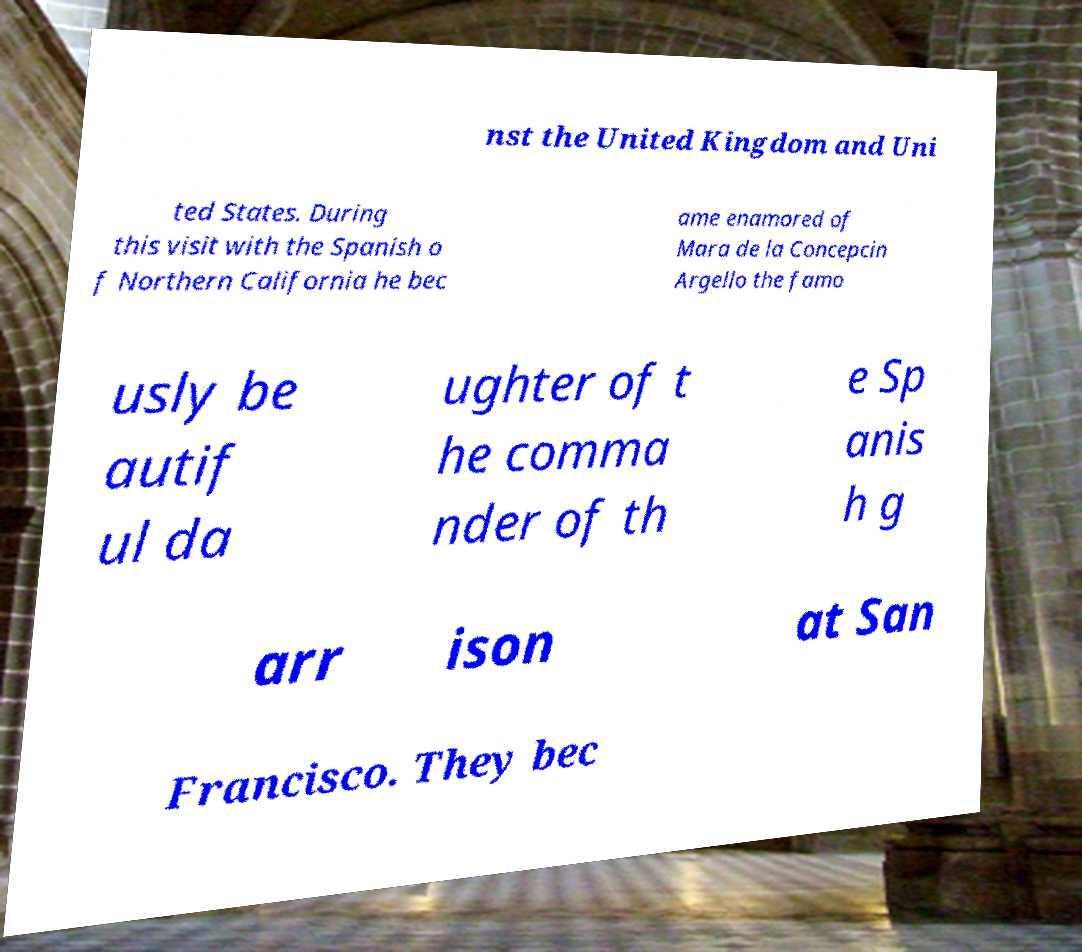Could you extract and type out the text from this image? nst the United Kingdom and Uni ted States. During this visit with the Spanish o f Northern California he bec ame enamored of Mara de la Concepcin Argello the famo usly be autif ul da ughter of t he comma nder of th e Sp anis h g arr ison at San Francisco. They bec 